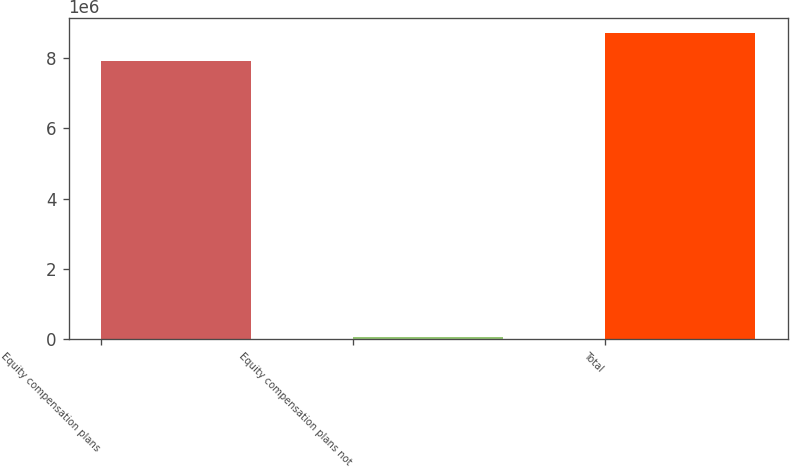<chart> <loc_0><loc_0><loc_500><loc_500><bar_chart><fcel>Equity compensation plans<fcel>Equity compensation plans not<fcel>Total<nl><fcel>7.92016e+06<fcel>43182<fcel>8.71218e+06<nl></chart> 